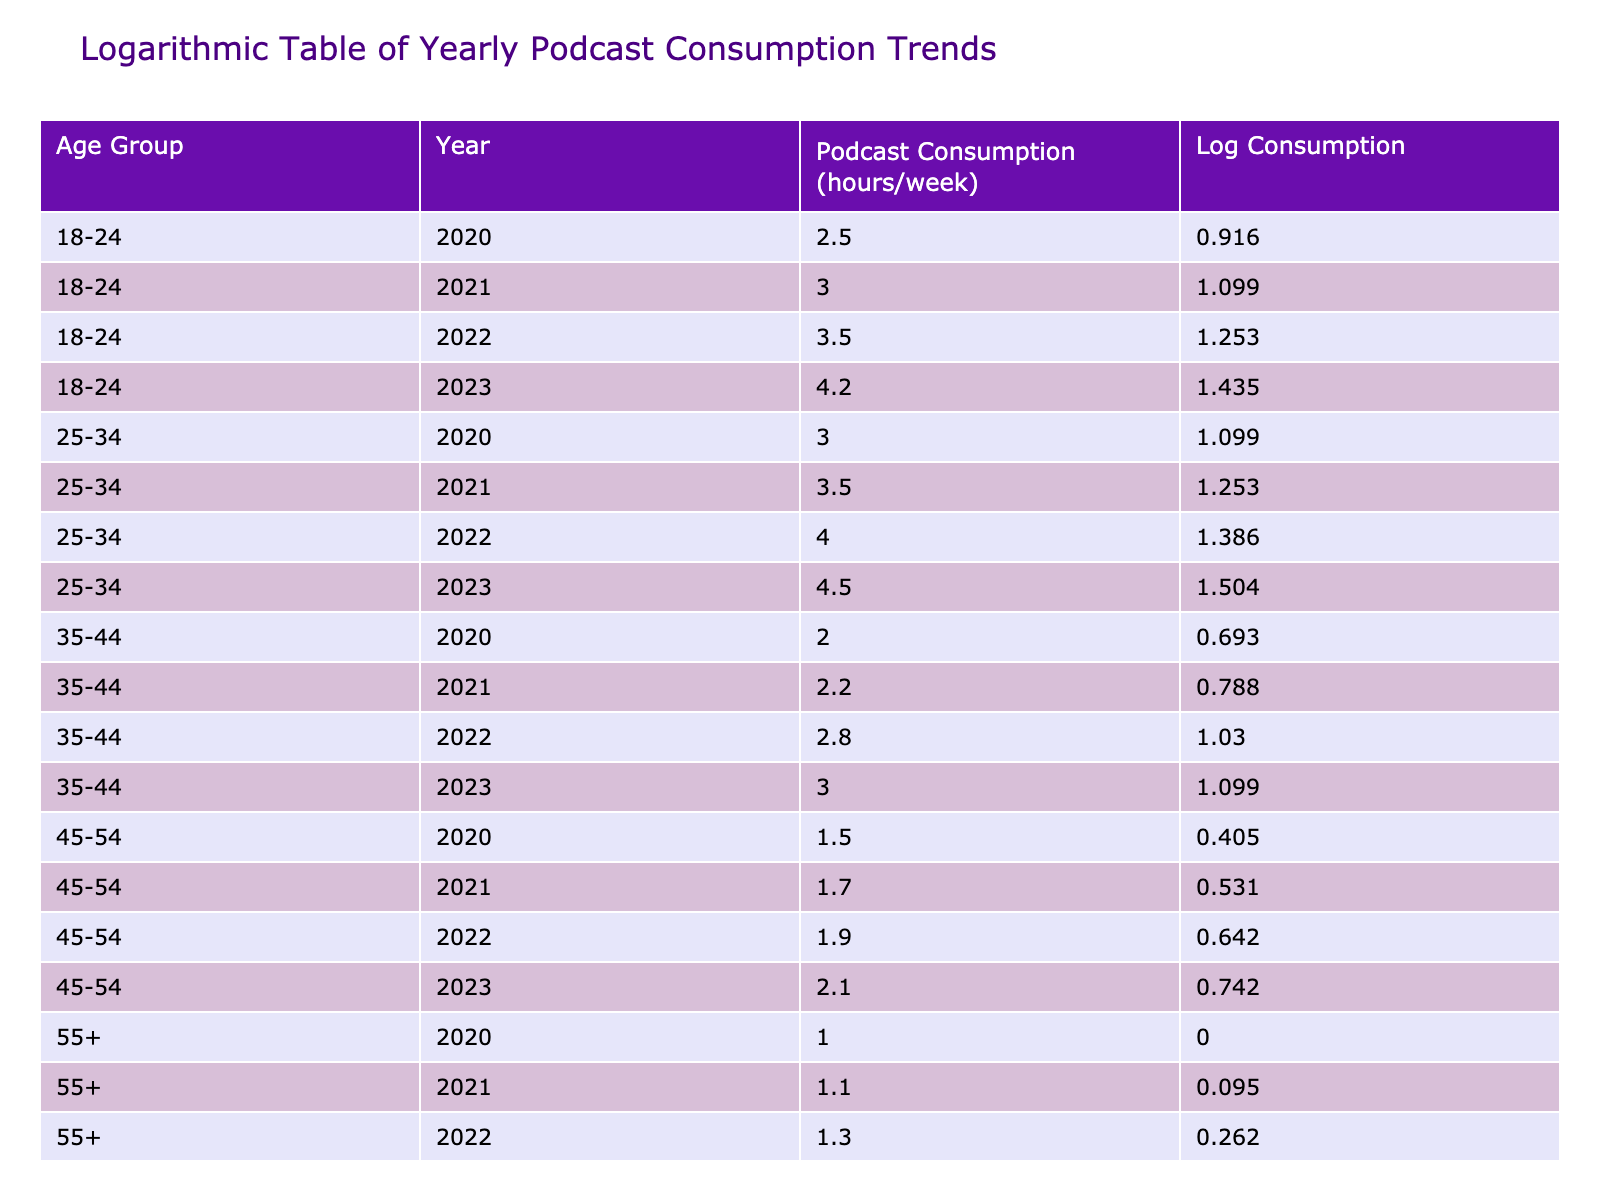What is the podcast consumption for the age group 25-34 in 2022? According to the table, for the age group 25-34 in the year 2022, the podcast consumption is listed as 4.0 hours per week.
Answer: 4.0 hours What is the average podcast consumption of the age group 35-44 over the years? We take the podcast consumption hours for the age group 35-44 from the years 2020 to 2023, which are 2.0, 2.2, 2.8, and 3.0. The sum is 2.0 + 2.2 + 2.8 + 3.0 = 10.0. There are 4 data points, so the average is 10.0 / 4 = 2.5.
Answer: 2.5 hours Did the podcast consumption for the age group 55+ increase from 2021 to 2023? By looking at the table, the podcast consumption for the age group 55+ in 2021 is 1.1 hours and in 2023 is 1.5 hours. Since 1.1 is less than 1.5, the consumption did increase.
Answer: Yes What is the logarithmic consumption value for the age group 45-54 in 2023? For the age group 45-54 in 2023, the podcast consumption recorded is 2.1 hours. When we calculate the logarithmic value of 2.1, we find it equals approximately 0.741.
Answer: 0.741 Which age group had the highest podcast consumption in 2023? In the table, for the year 2023, the age group 18-24 has 4.2 hours, and the age group 25-34 has 4.5 hours, while older groups have lower values. Therefore, the age group 25-34 had the highest podcast consumption in 2023.
Answer: 25-34 